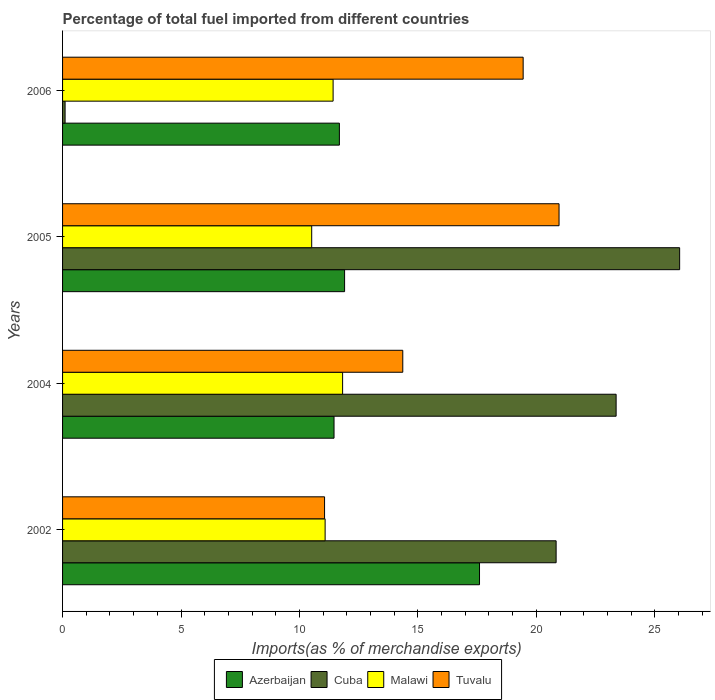Are the number of bars per tick equal to the number of legend labels?
Your answer should be compact. Yes. How many bars are there on the 4th tick from the bottom?
Offer a very short reply. 4. What is the label of the 4th group of bars from the top?
Ensure brevity in your answer.  2002. What is the percentage of imports to different countries in Malawi in 2005?
Ensure brevity in your answer.  10.52. Across all years, what is the maximum percentage of imports to different countries in Tuvalu?
Give a very brief answer. 20.96. Across all years, what is the minimum percentage of imports to different countries in Tuvalu?
Offer a terse response. 11.06. In which year was the percentage of imports to different countries in Malawi maximum?
Provide a short and direct response. 2004. In which year was the percentage of imports to different countries in Azerbaijan minimum?
Ensure brevity in your answer.  2004. What is the total percentage of imports to different countries in Tuvalu in the graph?
Provide a succinct answer. 65.83. What is the difference between the percentage of imports to different countries in Tuvalu in 2002 and that in 2006?
Offer a very short reply. -8.38. What is the difference between the percentage of imports to different countries in Malawi in 2006 and the percentage of imports to different countries in Azerbaijan in 2002?
Keep it short and to the point. -6.18. What is the average percentage of imports to different countries in Azerbaijan per year?
Offer a very short reply. 13.16. In the year 2004, what is the difference between the percentage of imports to different countries in Cuba and percentage of imports to different countries in Malawi?
Keep it short and to the point. 11.55. What is the ratio of the percentage of imports to different countries in Cuba in 2002 to that in 2006?
Provide a short and direct response. 195.38. Is the difference between the percentage of imports to different countries in Cuba in 2002 and 2004 greater than the difference between the percentage of imports to different countries in Malawi in 2002 and 2004?
Your response must be concise. No. What is the difference between the highest and the second highest percentage of imports to different countries in Malawi?
Provide a succinct answer. 0.4. What is the difference between the highest and the lowest percentage of imports to different countries in Azerbaijan?
Offer a very short reply. 6.14. What does the 3rd bar from the top in 2006 represents?
Your answer should be compact. Cuba. What does the 4th bar from the bottom in 2005 represents?
Offer a terse response. Tuvalu. Is it the case that in every year, the sum of the percentage of imports to different countries in Cuba and percentage of imports to different countries in Azerbaijan is greater than the percentage of imports to different countries in Malawi?
Ensure brevity in your answer.  Yes. What is the difference between two consecutive major ticks on the X-axis?
Ensure brevity in your answer.  5. Are the values on the major ticks of X-axis written in scientific E-notation?
Your answer should be compact. No. Does the graph contain any zero values?
Keep it short and to the point. No. Does the graph contain grids?
Give a very brief answer. No. What is the title of the graph?
Give a very brief answer. Percentage of total fuel imported from different countries. What is the label or title of the X-axis?
Keep it short and to the point. Imports(as % of merchandise exports). What is the Imports(as % of merchandise exports) in Azerbaijan in 2002?
Your answer should be compact. 17.6. What is the Imports(as % of merchandise exports) in Cuba in 2002?
Provide a succinct answer. 20.84. What is the Imports(as % of merchandise exports) in Malawi in 2002?
Give a very brief answer. 11.08. What is the Imports(as % of merchandise exports) in Tuvalu in 2002?
Provide a short and direct response. 11.06. What is the Imports(as % of merchandise exports) of Azerbaijan in 2004?
Offer a very short reply. 11.46. What is the Imports(as % of merchandise exports) of Cuba in 2004?
Your response must be concise. 23.37. What is the Imports(as % of merchandise exports) of Malawi in 2004?
Your answer should be compact. 11.82. What is the Imports(as % of merchandise exports) in Tuvalu in 2004?
Your answer should be very brief. 14.36. What is the Imports(as % of merchandise exports) in Azerbaijan in 2005?
Your response must be concise. 11.91. What is the Imports(as % of merchandise exports) of Cuba in 2005?
Your answer should be very brief. 26.05. What is the Imports(as % of merchandise exports) of Malawi in 2005?
Keep it short and to the point. 10.52. What is the Imports(as % of merchandise exports) of Tuvalu in 2005?
Provide a succinct answer. 20.96. What is the Imports(as % of merchandise exports) of Azerbaijan in 2006?
Your response must be concise. 11.69. What is the Imports(as % of merchandise exports) of Cuba in 2006?
Make the answer very short. 0.11. What is the Imports(as % of merchandise exports) in Malawi in 2006?
Your response must be concise. 11.42. What is the Imports(as % of merchandise exports) in Tuvalu in 2006?
Give a very brief answer. 19.44. Across all years, what is the maximum Imports(as % of merchandise exports) of Azerbaijan?
Ensure brevity in your answer.  17.6. Across all years, what is the maximum Imports(as % of merchandise exports) of Cuba?
Ensure brevity in your answer.  26.05. Across all years, what is the maximum Imports(as % of merchandise exports) in Malawi?
Your answer should be very brief. 11.82. Across all years, what is the maximum Imports(as % of merchandise exports) of Tuvalu?
Offer a very short reply. 20.96. Across all years, what is the minimum Imports(as % of merchandise exports) of Azerbaijan?
Your response must be concise. 11.46. Across all years, what is the minimum Imports(as % of merchandise exports) in Cuba?
Provide a short and direct response. 0.11. Across all years, what is the minimum Imports(as % of merchandise exports) of Malawi?
Give a very brief answer. 10.52. Across all years, what is the minimum Imports(as % of merchandise exports) of Tuvalu?
Ensure brevity in your answer.  11.06. What is the total Imports(as % of merchandise exports) of Azerbaijan in the graph?
Make the answer very short. 52.66. What is the total Imports(as % of merchandise exports) in Cuba in the graph?
Provide a short and direct response. 70.36. What is the total Imports(as % of merchandise exports) of Malawi in the graph?
Offer a terse response. 44.85. What is the total Imports(as % of merchandise exports) in Tuvalu in the graph?
Your response must be concise. 65.83. What is the difference between the Imports(as % of merchandise exports) of Azerbaijan in 2002 and that in 2004?
Your answer should be compact. 6.14. What is the difference between the Imports(as % of merchandise exports) in Cuba in 2002 and that in 2004?
Your response must be concise. -2.53. What is the difference between the Imports(as % of merchandise exports) of Malawi in 2002 and that in 2004?
Give a very brief answer. -0.74. What is the difference between the Imports(as % of merchandise exports) in Tuvalu in 2002 and that in 2004?
Provide a succinct answer. -3.3. What is the difference between the Imports(as % of merchandise exports) in Azerbaijan in 2002 and that in 2005?
Offer a very short reply. 5.7. What is the difference between the Imports(as % of merchandise exports) of Cuba in 2002 and that in 2005?
Offer a very short reply. -5.21. What is the difference between the Imports(as % of merchandise exports) in Malawi in 2002 and that in 2005?
Your answer should be compact. 0.57. What is the difference between the Imports(as % of merchandise exports) in Tuvalu in 2002 and that in 2005?
Provide a short and direct response. -9.9. What is the difference between the Imports(as % of merchandise exports) in Azerbaijan in 2002 and that in 2006?
Provide a short and direct response. 5.92. What is the difference between the Imports(as % of merchandise exports) in Cuba in 2002 and that in 2006?
Provide a succinct answer. 20.73. What is the difference between the Imports(as % of merchandise exports) of Malawi in 2002 and that in 2006?
Your response must be concise. -0.34. What is the difference between the Imports(as % of merchandise exports) of Tuvalu in 2002 and that in 2006?
Keep it short and to the point. -8.38. What is the difference between the Imports(as % of merchandise exports) in Azerbaijan in 2004 and that in 2005?
Give a very brief answer. -0.45. What is the difference between the Imports(as % of merchandise exports) in Cuba in 2004 and that in 2005?
Make the answer very short. -2.68. What is the difference between the Imports(as % of merchandise exports) in Malawi in 2004 and that in 2005?
Your answer should be very brief. 1.3. What is the difference between the Imports(as % of merchandise exports) in Tuvalu in 2004 and that in 2005?
Keep it short and to the point. -6.6. What is the difference between the Imports(as % of merchandise exports) in Azerbaijan in 2004 and that in 2006?
Offer a very short reply. -0.23. What is the difference between the Imports(as % of merchandise exports) of Cuba in 2004 and that in 2006?
Make the answer very short. 23.26. What is the difference between the Imports(as % of merchandise exports) in Malawi in 2004 and that in 2006?
Offer a very short reply. 0.4. What is the difference between the Imports(as % of merchandise exports) in Tuvalu in 2004 and that in 2006?
Offer a very short reply. -5.08. What is the difference between the Imports(as % of merchandise exports) of Azerbaijan in 2005 and that in 2006?
Offer a very short reply. 0.22. What is the difference between the Imports(as % of merchandise exports) of Cuba in 2005 and that in 2006?
Offer a terse response. 25.94. What is the difference between the Imports(as % of merchandise exports) in Malawi in 2005 and that in 2006?
Your answer should be compact. -0.9. What is the difference between the Imports(as % of merchandise exports) in Tuvalu in 2005 and that in 2006?
Offer a terse response. 1.52. What is the difference between the Imports(as % of merchandise exports) of Azerbaijan in 2002 and the Imports(as % of merchandise exports) of Cuba in 2004?
Offer a terse response. -5.77. What is the difference between the Imports(as % of merchandise exports) in Azerbaijan in 2002 and the Imports(as % of merchandise exports) in Malawi in 2004?
Offer a very short reply. 5.78. What is the difference between the Imports(as % of merchandise exports) of Azerbaijan in 2002 and the Imports(as % of merchandise exports) of Tuvalu in 2004?
Make the answer very short. 3.24. What is the difference between the Imports(as % of merchandise exports) in Cuba in 2002 and the Imports(as % of merchandise exports) in Malawi in 2004?
Give a very brief answer. 9.01. What is the difference between the Imports(as % of merchandise exports) of Cuba in 2002 and the Imports(as % of merchandise exports) of Tuvalu in 2004?
Give a very brief answer. 6.47. What is the difference between the Imports(as % of merchandise exports) in Malawi in 2002 and the Imports(as % of merchandise exports) in Tuvalu in 2004?
Make the answer very short. -3.28. What is the difference between the Imports(as % of merchandise exports) in Azerbaijan in 2002 and the Imports(as % of merchandise exports) in Cuba in 2005?
Make the answer very short. -8.45. What is the difference between the Imports(as % of merchandise exports) in Azerbaijan in 2002 and the Imports(as % of merchandise exports) in Malawi in 2005?
Keep it short and to the point. 7.08. What is the difference between the Imports(as % of merchandise exports) in Azerbaijan in 2002 and the Imports(as % of merchandise exports) in Tuvalu in 2005?
Your response must be concise. -3.36. What is the difference between the Imports(as % of merchandise exports) of Cuba in 2002 and the Imports(as % of merchandise exports) of Malawi in 2005?
Offer a terse response. 10.32. What is the difference between the Imports(as % of merchandise exports) of Cuba in 2002 and the Imports(as % of merchandise exports) of Tuvalu in 2005?
Give a very brief answer. -0.12. What is the difference between the Imports(as % of merchandise exports) of Malawi in 2002 and the Imports(as % of merchandise exports) of Tuvalu in 2005?
Provide a succinct answer. -9.88. What is the difference between the Imports(as % of merchandise exports) of Azerbaijan in 2002 and the Imports(as % of merchandise exports) of Cuba in 2006?
Make the answer very short. 17.5. What is the difference between the Imports(as % of merchandise exports) in Azerbaijan in 2002 and the Imports(as % of merchandise exports) in Malawi in 2006?
Offer a very short reply. 6.18. What is the difference between the Imports(as % of merchandise exports) in Azerbaijan in 2002 and the Imports(as % of merchandise exports) in Tuvalu in 2006?
Your answer should be compact. -1.84. What is the difference between the Imports(as % of merchandise exports) of Cuba in 2002 and the Imports(as % of merchandise exports) of Malawi in 2006?
Provide a succinct answer. 9.41. What is the difference between the Imports(as % of merchandise exports) of Cuba in 2002 and the Imports(as % of merchandise exports) of Tuvalu in 2006?
Ensure brevity in your answer.  1.39. What is the difference between the Imports(as % of merchandise exports) of Malawi in 2002 and the Imports(as % of merchandise exports) of Tuvalu in 2006?
Your answer should be compact. -8.36. What is the difference between the Imports(as % of merchandise exports) in Azerbaijan in 2004 and the Imports(as % of merchandise exports) in Cuba in 2005?
Give a very brief answer. -14.59. What is the difference between the Imports(as % of merchandise exports) in Azerbaijan in 2004 and the Imports(as % of merchandise exports) in Malawi in 2005?
Your answer should be very brief. 0.94. What is the difference between the Imports(as % of merchandise exports) of Azerbaijan in 2004 and the Imports(as % of merchandise exports) of Tuvalu in 2005?
Offer a very short reply. -9.5. What is the difference between the Imports(as % of merchandise exports) of Cuba in 2004 and the Imports(as % of merchandise exports) of Malawi in 2005?
Offer a very short reply. 12.85. What is the difference between the Imports(as % of merchandise exports) in Cuba in 2004 and the Imports(as % of merchandise exports) in Tuvalu in 2005?
Make the answer very short. 2.41. What is the difference between the Imports(as % of merchandise exports) of Malawi in 2004 and the Imports(as % of merchandise exports) of Tuvalu in 2005?
Your answer should be compact. -9.14. What is the difference between the Imports(as % of merchandise exports) in Azerbaijan in 2004 and the Imports(as % of merchandise exports) in Cuba in 2006?
Keep it short and to the point. 11.35. What is the difference between the Imports(as % of merchandise exports) of Azerbaijan in 2004 and the Imports(as % of merchandise exports) of Malawi in 2006?
Your answer should be very brief. 0.04. What is the difference between the Imports(as % of merchandise exports) of Azerbaijan in 2004 and the Imports(as % of merchandise exports) of Tuvalu in 2006?
Give a very brief answer. -7.98. What is the difference between the Imports(as % of merchandise exports) of Cuba in 2004 and the Imports(as % of merchandise exports) of Malawi in 2006?
Give a very brief answer. 11.95. What is the difference between the Imports(as % of merchandise exports) of Cuba in 2004 and the Imports(as % of merchandise exports) of Tuvalu in 2006?
Keep it short and to the point. 3.92. What is the difference between the Imports(as % of merchandise exports) in Malawi in 2004 and the Imports(as % of merchandise exports) in Tuvalu in 2006?
Your answer should be compact. -7.62. What is the difference between the Imports(as % of merchandise exports) in Azerbaijan in 2005 and the Imports(as % of merchandise exports) in Cuba in 2006?
Offer a terse response. 11.8. What is the difference between the Imports(as % of merchandise exports) of Azerbaijan in 2005 and the Imports(as % of merchandise exports) of Malawi in 2006?
Give a very brief answer. 0.48. What is the difference between the Imports(as % of merchandise exports) in Azerbaijan in 2005 and the Imports(as % of merchandise exports) in Tuvalu in 2006?
Ensure brevity in your answer.  -7.54. What is the difference between the Imports(as % of merchandise exports) of Cuba in 2005 and the Imports(as % of merchandise exports) of Malawi in 2006?
Your answer should be very brief. 14.63. What is the difference between the Imports(as % of merchandise exports) of Cuba in 2005 and the Imports(as % of merchandise exports) of Tuvalu in 2006?
Give a very brief answer. 6.61. What is the difference between the Imports(as % of merchandise exports) of Malawi in 2005 and the Imports(as % of merchandise exports) of Tuvalu in 2006?
Offer a terse response. -8.93. What is the average Imports(as % of merchandise exports) in Azerbaijan per year?
Your answer should be very brief. 13.16. What is the average Imports(as % of merchandise exports) of Cuba per year?
Provide a succinct answer. 17.59. What is the average Imports(as % of merchandise exports) in Malawi per year?
Make the answer very short. 11.21. What is the average Imports(as % of merchandise exports) of Tuvalu per year?
Provide a succinct answer. 16.46. In the year 2002, what is the difference between the Imports(as % of merchandise exports) of Azerbaijan and Imports(as % of merchandise exports) of Cuba?
Provide a succinct answer. -3.23. In the year 2002, what is the difference between the Imports(as % of merchandise exports) in Azerbaijan and Imports(as % of merchandise exports) in Malawi?
Offer a terse response. 6.52. In the year 2002, what is the difference between the Imports(as % of merchandise exports) of Azerbaijan and Imports(as % of merchandise exports) of Tuvalu?
Ensure brevity in your answer.  6.54. In the year 2002, what is the difference between the Imports(as % of merchandise exports) in Cuba and Imports(as % of merchandise exports) in Malawi?
Your answer should be very brief. 9.75. In the year 2002, what is the difference between the Imports(as % of merchandise exports) of Cuba and Imports(as % of merchandise exports) of Tuvalu?
Make the answer very short. 9.78. In the year 2002, what is the difference between the Imports(as % of merchandise exports) of Malawi and Imports(as % of merchandise exports) of Tuvalu?
Give a very brief answer. 0.02. In the year 2004, what is the difference between the Imports(as % of merchandise exports) of Azerbaijan and Imports(as % of merchandise exports) of Cuba?
Provide a short and direct response. -11.91. In the year 2004, what is the difference between the Imports(as % of merchandise exports) in Azerbaijan and Imports(as % of merchandise exports) in Malawi?
Make the answer very short. -0.36. In the year 2004, what is the difference between the Imports(as % of merchandise exports) in Azerbaijan and Imports(as % of merchandise exports) in Tuvalu?
Make the answer very short. -2.9. In the year 2004, what is the difference between the Imports(as % of merchandise exports) in Cuba and Imports(as % of merchandise exports) in Malawi?
Ensure brevity in your answer.  11.55. In the year 2004, what is the difference between the Imports(as % of merchandise exports) of Cuba and Imports(as % of merchandise exports) of Tuvalu?
Provide a succinct answer. 9.01. In the year 2004, what is the difference between the Imports(as % of merchandise exports) of Malawi and Imports(as % of merchandise exports) of Tuvalu?
Provide a succinct answer. -2.54. In the year 2005, what is the difference between the Imports(as % of merchandise exports) of Azerbaijan and Imports(as % of merchandise exports) of Cuba?
Keep it short and to the point. -14.14. In the year 2005, what is the difference between the Imports(as % of merchandise exports) of Azerbaijan and Imports(as % of merchandise exports) of Malawi?
Ensure brevity in your answer.  1.39. In the year 2005, what is the difference between the Imports(as % of merchandise exports) of Azerbaijan and Imports(as % of merchandise exports) of Tuvalu?
Keep it short and to the point. -9.05. In the year 2005, what is the difference between the Imports(as % of merchandise exports) in Cuba and Imports(as % of merchandise exports) in Malawi?
Your answer should be compact. 15.53. In the year 2005, what is the difference between the Imports(as % of merchandise exports) in Cuba and Imports(as % of merchandise exports) in Tuvalu?
Provide a short and direct response. 5.09. In the year 2005, what is the difference between the Imports(as % of merchandise exports) of Malawi and Imports(as % of merchandise exports) of Tuvalu?
Provide a short and direct response. -10.44. In the year 2006, what is the difference between the Imports(as % of merchandise exports) in Azerbaijan and Imports(as % of merchandise exports) in Cuba?
Ensure brevity in your answer.  11.58. In the year 2006, what is the difference between the Imports(as % of merchandise exports) in Azerbaijan and Imports(as % of merchandise exports) in Malawi?
Ensure brevity in your answer.  0.27. In the year 2006, what is the difference between the Imports(as % of merchandise exports) of Azerbaijan and Imports(as % of merchandise exports) of Tuvalu?
Give a very brief answer. -7.76. In the year 2006, what is the difference between the Imports(as % of merchandise exports) in Cuba and Imports(as % of merchandise exports) in Malawi?
Provide a succinct answer. -11.31. In the year 2006, what is the difference between the Imports(as % of merchandise exports) of Cuba and Imports(as % of merchandise exports) of Tuvalu?
Provide a short and direct response. -19.34. In the year 2006, what is the difference between the Imports(as % of merchandise exports) in Malawi and Imports(as % of merchandise exports) in Tuvalu?
Provide a succinct answer. -8.02. What is the ratio of the Imports(as % of merchandise exports) of Azerbaijan in 2002 to that in 2004?
Your response must be concise. 1.54. What is the ratio of the Imports(as % of merchandise exports) of Cuba in 2002 to that in 2004?
Your answer should be very brief. 0.89. What is the ratio of the Imports(as % of merchandise exports) in Tuvalu in 2002 to that in 2004?
Your answer should be very brief. 0.77. What is the ratio of the Imports(as % of merchandise exports) in Azerbaijan in 2002 to that in 2005?
Keep it short and to the point. 1.48. What is the ratio of the Imports(as % of merchandise exports) of Cuba in 2002 to that in 2005?
Your response must be concise. 0.8. What is the ratio of the Imports(as % of merchandise exports) of Malawi in 2002 to that in 2005?
Keep it short and to the point. 1.05. What is the ratio of the Imports(as % of merchandise exports) in Tuvalu in 2002 to that in 2005?
Your answer should be very brief. 0.53. What is the ratio of the Imports(as % of merchandise exports) of Azerbaijan in 2002 to that in 2006?
Offer a very short reply. 1.51. What is the ratio of the Imports(as % of merchandise exports) of Cuba in 2002 to that in 2006?
Give a very brief answer. 195.38. What is the ratio of the Imports(as % of merchandise exports) of Malawi in 2002 to that in 2006?
Provide a succinct answer. 0.97. What is the ratio of the Imports(as % of merchandise exports) in Tuvalu in 2002 to that in 2006?
Offer a very short reply. 0.57. What is the ratio of the Imports(as % of merchandise exports) of Azerbaijan in 2004 to that in 2005?
Your answer should be compact. 0.96. What is the ratio of the Imports(as % of merchandise exports) of Cuba in 2004 to that in 2005?
Keep it short and to the point. 0.9. What is the ratio of the Imports(as % of merchandise exports) of Malawi in 2004 to that in 2005?
Provide a short and direct response. 1.12. What is the ratio of the Imports(as % of merchandise exports) of Tuvalu in 2004 to that in 2005?
Offer a very short reply. 0.69. What is the ratio of the Imports(as % of merchandise exports) of Azerbaijan in 2004 to that in 2006?
Your response must be concise. 0.98. What is the ratio of the Imports(as % of merchandise exports) in Cuba in 2004 to that in 2006?
Your response must be concise. 219.14. What is the ratio of the Imports(as % of merchandise exports) in Malawi in 2004 to that in 2006?
Keep it short and to the point. 1.04. What is the ratio of the Imports(as % of merchandise exports) in Tuvalu in 2004 to that in 2006?
Your response must be concise. 0.74. What is the ratio of the Imports(as % of merchandise exports) in Azerbaijan in 2005 to that in 2006?
Your answer should be compact. 1.02. What is the ratio of the Imports(as % of merchandise exports) in Cuba in 2005 to that in 2006?
Your response must be concise. 244.28. What is the ratio of the Imports(as % of merchandise exports) of Malawi in 2005 to that in 2006?
Give a very brief answer. 0.92. What is the ratio of the Imports(as % of merchandise exports) in Tuvalu in 2005 to that in 2006?
Offer a very short reply. 1.08. What is the difference between the highest and the second highest Imports(as % of merchandise exports) of Azerbaijan?
Your response must be concise. 5.7. What is the difference between the highest and the second highest Imports(as % of merchandise exports) of Cuba?
Provide a succinct answer. 2.68. What is the difference between the highest and the second highest Imports(as % of merchandise exports) in Malawi?
Make the answer very short. 0.4. What is the difference between the highest and the second highest Imports(as % of merchandise exports) of Tuvalu?
Make the answer very short. 1.52. What is the difference between the highest and the lowest Imports(as % of merchandise exports) of Azerbaijan?
Your answer should be compact. 6.14. What is the difference between the highest and the lowest Imports(as % of merchandise exports) in Cuba?
Ensure brevity in your answer.  25.94. What is the difference between the highest and the lowest Imports(as % of merchandise exports) in Malawi?
Provide a short and direct response. 1.3. What is the difference between the highest and the lowest Imports(as % of merchandise exports) of Tuvalu?
Your answer should be very brief. 9.9. 